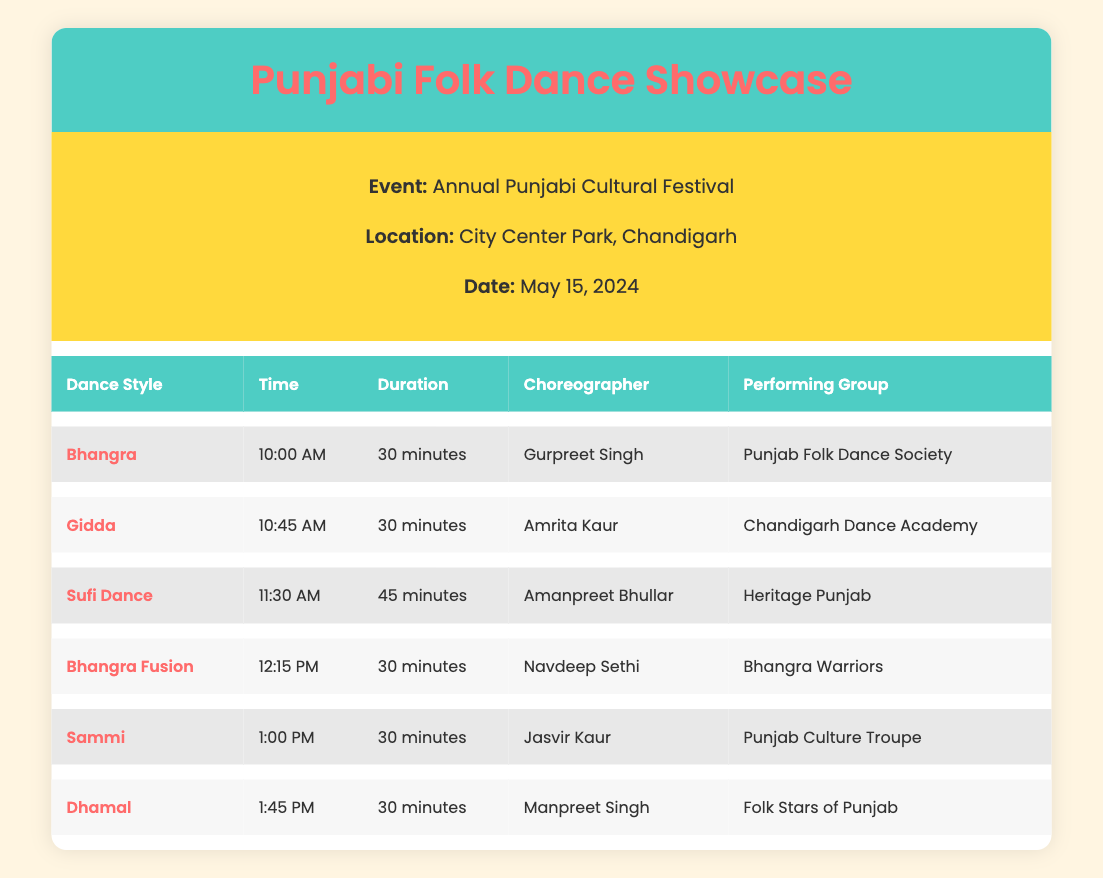What time does the Gidda performance start? The table shows that the Gidda performance starts at 10:45 AM.
Answer: 10:45 AM Who is the choreographer for the Bhangra dance? The choreographer for Bhangra is Gurpreet Singh as stated in the table.
Answer: Gurpreet Singh How long is the Sufi Dance performance? The duration for Sufi Dance is mentioned as 45 minutes in the table.
Answer: 45 minutes Which performing group is associated with the Sammi dance? The table indicates that the Sammi dance is performed by the Punjab Culture Troupe.
Answer: Punjab Culture Troupe Is there a dance performance scheduled after 1:00 PM? Yes, according to the table, there is a Dhamal performance scheduled right after Sammi at 1:45 PM.
Answer: Yes What is the total duration of performances scheduled before 12:15 PM? To find the total duration before 12:15 PM, we sum the durations of Bhangra (30 minutes), Gidda (30 minutes), and Sufi Dance (45 minutes). Thus, total is 30 + 30 + 45 = 105 minutes.
Answer: 105 minutes Which choreographer has the latest performance? The latest performance in the schedule is Dhamal at 1:45 PM, and the choreographer for this dance is Manpreet Singh.
Answer: Manpreet Singh Are there more performances by the Punjab Culture Troupe or the Chandigarh Dance Academy? The table shows that Punjab Culture Troupe has one performance (Sammi), and Chandigarh Dance Academy also has one performance (Gidda). Therefore, they have the same number of performances.
Answer: No What dance style has the same duration as Gidda? The Bhangra Fusion, Sammi, and Dhamal dances each have a duration of 30 minutes, which is the same as Gidda’s duration.
Answer: Bhangra Fusion, Sammi, Dhamal 